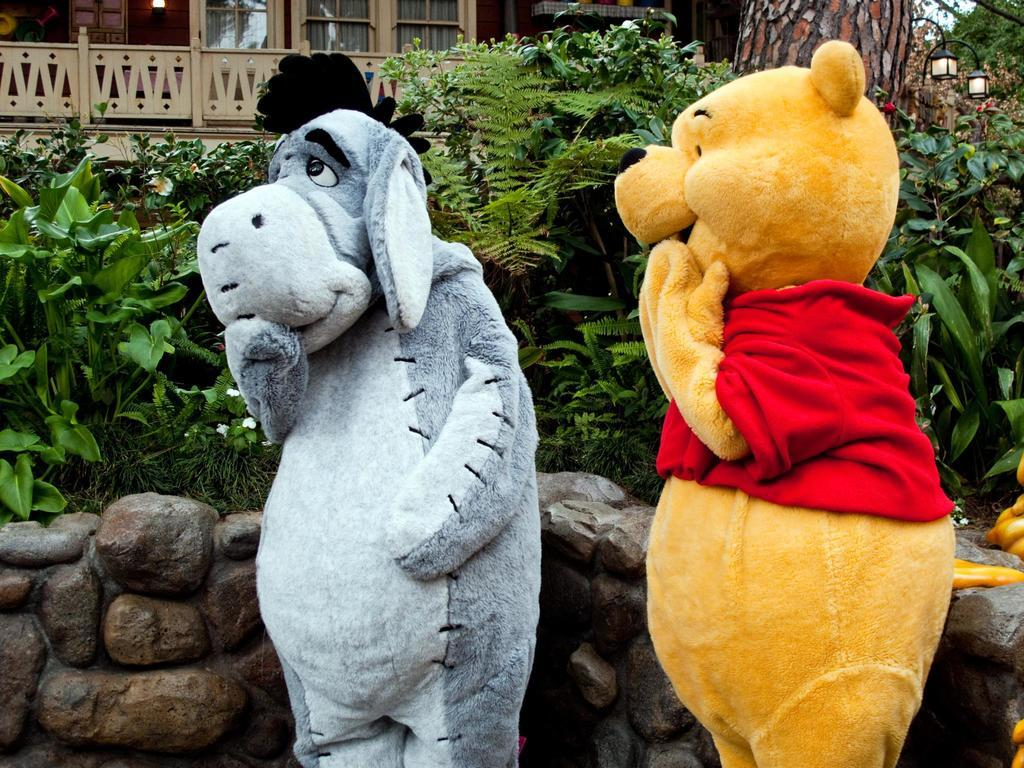How many mascots are present in the image? There are two mascots standing in the image. What else can be seen in the image besides the mascots? There are plants, a house, lamps, and a wall in the image. Can you describe the type of plants in the image? The provided facts do not specify the type of plants in the image. What is the purpose of the lamps in the image? The purpose of the lamps in the image is not specified by the provided facts. What is the result of 2 + 2 in the image? The provided facts do not mention any arithmetic or calculations in the image. The result of 2 + 2 is 4, but this cannot be determined from the image. 